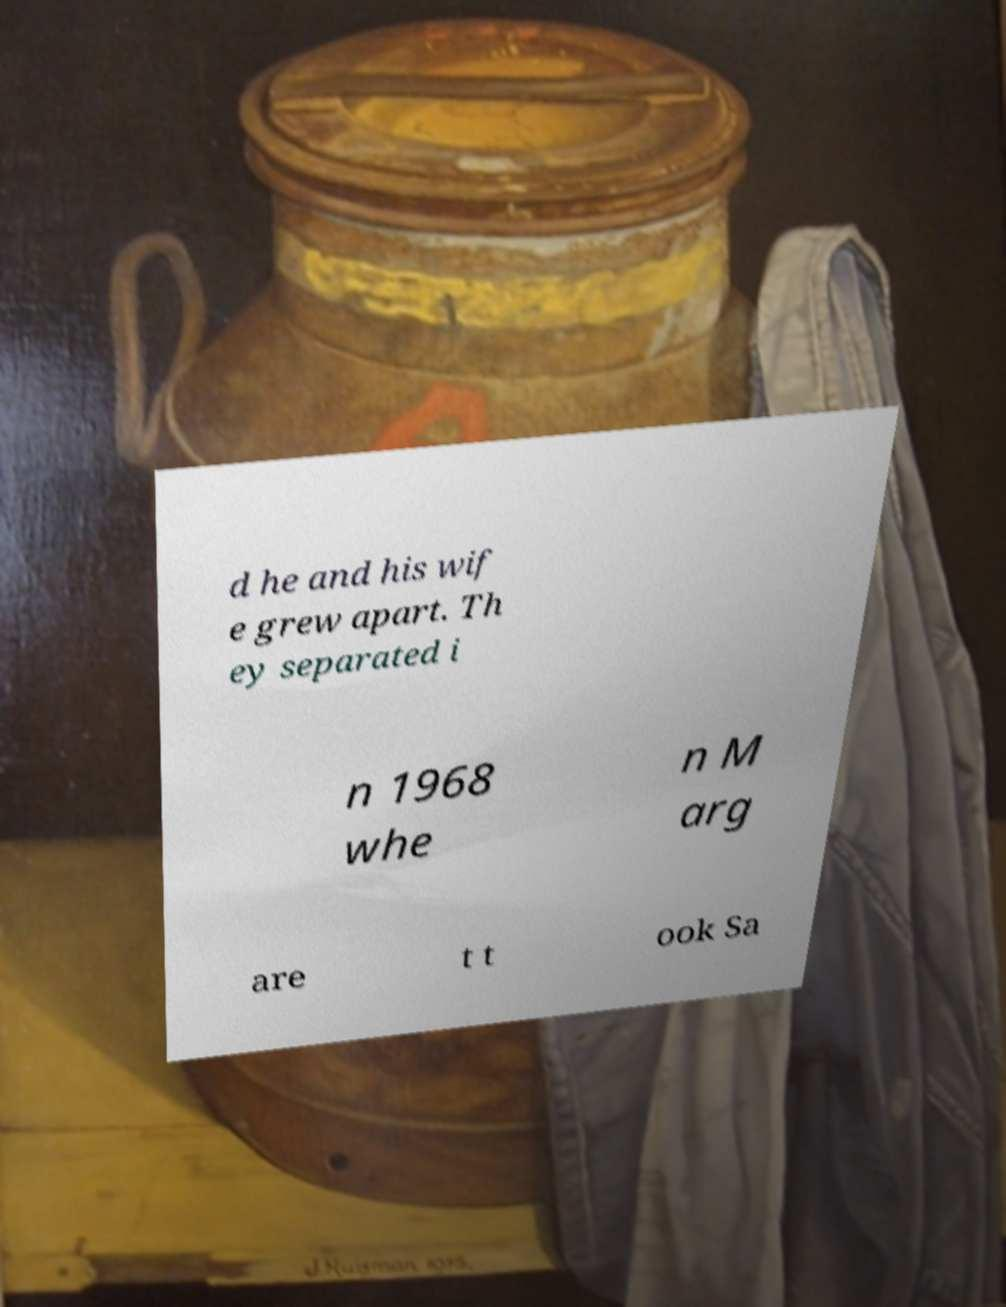What messages or text are displayed in this image? I need them in a readable, typed format. d he and his wif e grew apart. Th ey separated i n 1968 whe n M arg are t t ook Sa 